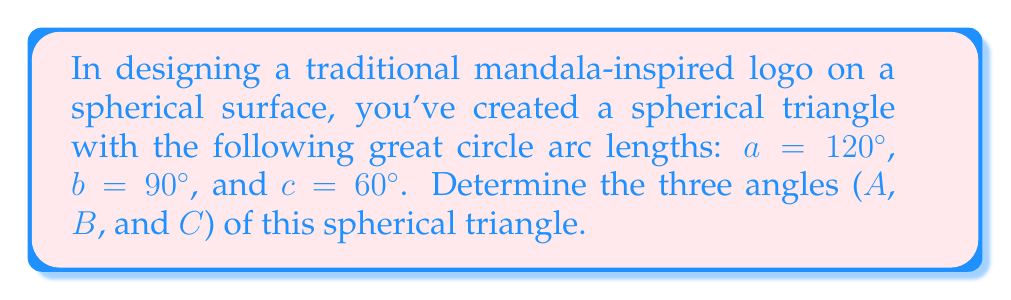Can you solve this math problem? To solve this problem, we'll use the spherical law of cosines. For a spherical triangle with sides a, b, and c, and opposite angles A, B, and C, the law states:

$$\cos(a) = \cos(b)\cos(c) + \sin(b)\sin(c)\cos(A)$$

We can rearrange this to solve for angle A:

$$\cos(A) = \frac{\cos(a) - \cos(b)\cos(c)}{\sin(b)\sin(c)}$$

Step 1: Calculate angle A
$$\cos(A) = \frac{\cos(120°) - \cos(90°)\cos(60°)}{\sin(90°)\sin(60°)}$$
$$= \frac{-0.5 - 0 \cdot 0.5}{1 \cdot \frac{\sqrt{3}}{2}} = \frac{-0.5}{\frac{\sqrt{3}}{2}} = -\frac{1}{\sqrt{3}}$$
$$A = \arccos(-\frac{1}{\sqrt{3}}) \approx 125.26°$$

Step 2: Calculate angle B (using the same formula, cycled)
$$\cos(B) = \frac{\cos(90°) - \cos(120°)\cos(60°)}{\sin(120°)\sin(60°)}$$
$$= \frac{0 - (-0.5 \cdot 0.5)}{\frac{\sqrt{3}}{2} \cdot \frac{\sqrt{3}}{2}} = \frac{0.25}{0.75} = \frac{1}{3}$$
$$B = \arccos(\frac{1}{3}) \approx 70.53°$$

Step 3: Calculate angle C
$$\cos(C) = \frac{\cos(60°) - \cos(120°)\cos(90°)}{\sin(120°)\sin(90°)}$$
$$= \frac{0.5 - (-0.5 \cdot 0)}{(\frac{\sqrt{3}}{2}) \cdot 1} = \frac{0.5}{\frac{\sqrt{3}}{2}} = \frac{1}{\sqrt{3}}$$
$$C = \arccos(\frac{1}{\sqrt{3}}) \approx 54.74°$$

Step 4: Verify the result using the spherical angle sum theorem
The sum of angles in a spherical triangle should be between 180° and 540°. Our result:
$$125.26° + 70.53° + 54.74° = 250.53°$$
This falls within the expected range, confirming our calculations.
Answer: A ≈ 125.26°, B ≈ 70.53°, C ≈ 54.74° 